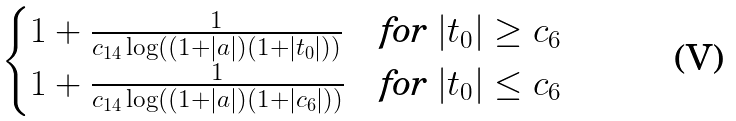<formula> <loc_0><loc_0><loc_500><loc_500>\begin{cases} 1 + \frac { 1 } { c _ { 1 4 } \log \left ( ( 1 + | a | ) ( 1 + | t _ { 0 } | ) \right ) } & \text {for } | t _ { 0 } | \geq c _ { 6 } \\ 1 + \frac { 1 } { c _ { 1 4 } \log \left ( ( 1 + | a | ) ( 1 + | c _ { 6 } | ) \right ) } & \text {for } | t _ { 0 } | \leq c _ { 6 } \end{cases}</formula> 